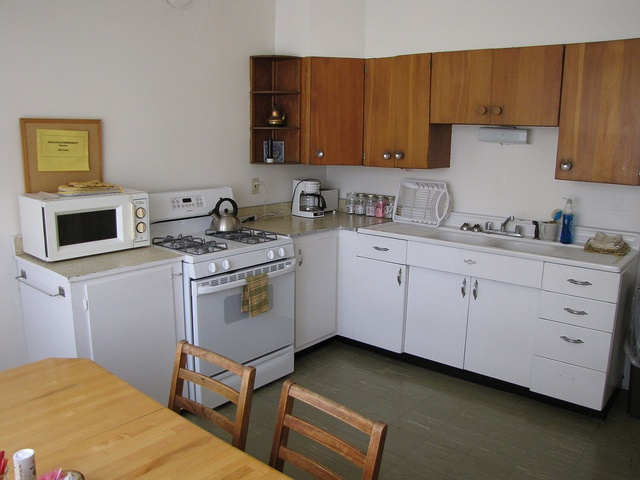Describe the objects in this image and their specific colors. I can see oven in darkgray and gray tones, dining table in darkgray, tan, and olive tones, microwave in darkgray, black, lightgray, and gray tones, chair in darkgray, maroon, gray, and brown tones, and chair in darkgray, maroon, and gray tones in this image. 